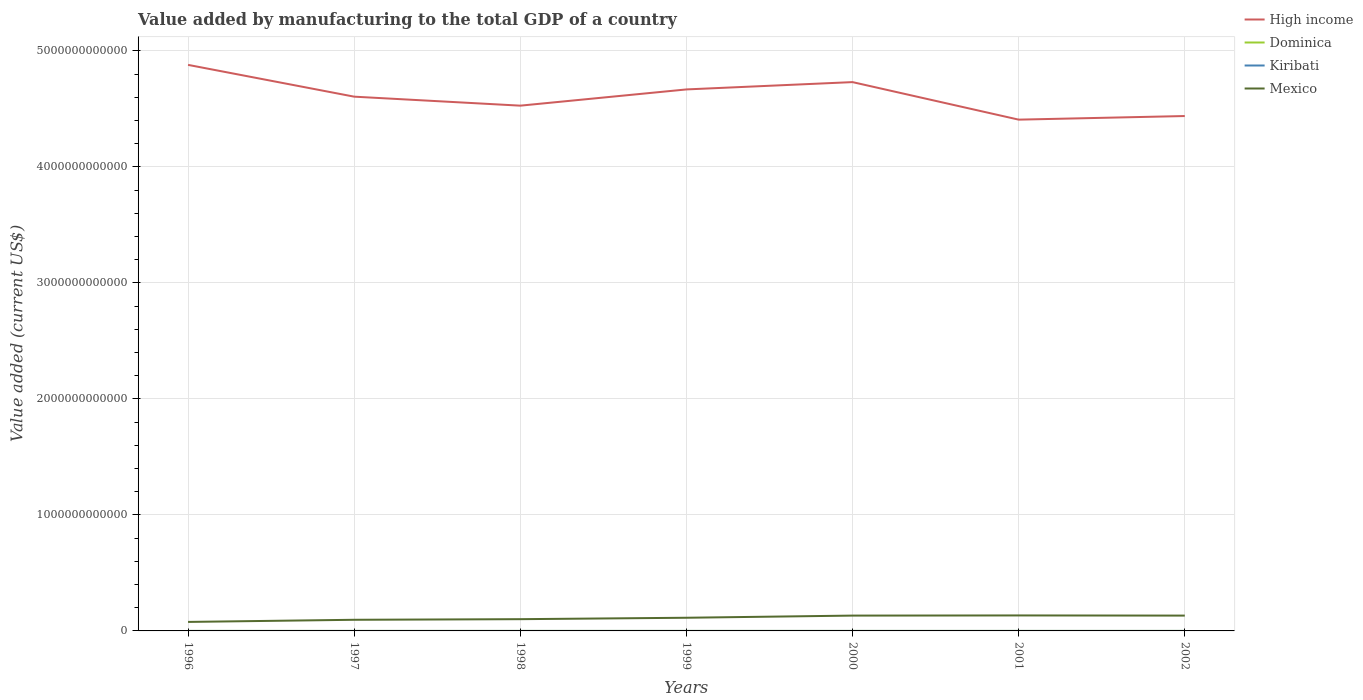Does the line corresponding to Mexico intersect with the line corresponding to Dominica?
Your response must be concise. No. Across all years, what is the maximum value added by manufacturing to the total GDP in Mexico?
Offer a terse response. 7.76e+1. What is the total value added by manufacturing to the total GDP in Mexico in the graph?
Offer a terse response. -5.45e+1. What is the difference between the highest and the second highest value added by manufacturing to the total GDP in Dominica?
Offer a very short reply. 1.43e+07. What is the difference between the highest and the lowest value added by manufacturing to the total GDP in Mexico?
Your answer should be compact. 4. Is the value added by manufacturing to the total GDP in Dominica strictly greater than the value added by manufacturing to the total GDP in High income over the years?
Make the answer very short. Yes. How many lines are there?
Your answer should be compact. 4. What is the difference between two consecutive major ticks on the Y-axis?
Provide a succinct answer. 1.00e+12. Are the values on the major ticks of Y-axis written in scientific E-notation?
Keep it short and to the point. No. Where does the legend appear in the graph?
Give a very brief answer. Top right. How are the legend labels stacked?
Your answer should be compact. Vertical. What is the title of the graph?
Ensure brevity in your answer.  Value added by manufacturing to the total GDP of a country. What is the label or title of the Y-axis?
Your answer should be compact. Value added (current US$). What is the Value added (current US$) in High income in 1996?
Give a very brief answer. 4.88e+12. What is the Value added (current US$) in Dominica in 1996?
Your response must be concise. 1.46e+07. What is the Value added (current US$) in Kiribati in 1996?
Your answer should be compact. 3.55e+06. What is the Value added (current US$) in Mexico in 1996?
Your response must be concise. 7.76e+1. What is the Value added (current US$) in High income in 1997?
Give a very brief answer. 4.61e+12. What is the Value added (current US$) in Dominica in 1997?
Offer a very short reply. 1.57e+07. What is the Value added (current US$) in Kiribati in 1997?
Make the answer very short. 3.47e+06. What is the Value added (current US$) in Mexico in 1997?
Ensure brevity in your answer.  9.60e+1. What is the Value added (current US$) in High income in 1998?
Keep it short and to the point. 4.53e+12. What is the Value added (current US$) in Dominica in 1998?
Make the answer very short. 1.88e+07. What is the Value added (current US$) of Kiribati in 1998?
Your answer should be compact. 3.13e+06. What is the Value added (current US$) in Mexico in 1998?
Your answer should be compact. 1.01e+11. What is the Value added (current US$) of High income in 1999?
Make the answer very short. 4.67e+12. What is the Value added (current US$) of Dominica in 1999?
Give a very brief answer. 1.83e+07. What is the Value added (current US$) of Kiribati in 1999?
Your answer should be compact. 3.52e+06. What is the Value added (current US$) of Mexico in 1999?
Your answer should be compact. 1.14e+11. What is the Value added (current US$) in High income in 2000?
Your answer should be compact. 4.73e+12. What is the Value added (current US$) in Dominica in 2000?
Ensure brevity in your answer.  2.29e+07. What is the Value added (current US$) of Kiribati in 2000?
Keep it short and to the point. 2.98e+06. What is the Value added (current US$) of Mexico in 2000?
Your response must be concise. 1.32e+11. What is the Value added (current US$) of High income in 2001?
Ensure brevity in your answer.  4.41e+12. What is the Value added (current US$) in Dominica in 2001?
Give a very brief answer. 2.42e+07. What is the Value added (current US$) in Kiribati in 2001?
Make the answer very short. 2.78e+06. What is the Value added (current US$) of Mexico in 2001?
Keep it short and to the point. 1.33e+11. What is the Value added (current US$) in High income in 2002?
Give a very brief answer. 4.44e+12. What is the Value added (current US$) in Dominica in 2002?
Your answer should be compact. 2.89e+07. What is the Value added (current US$) of Kiribati in 2002?
Ensure brevity in your answer.  2.85e+06. What is the Value added (current US$) of Mexico in 2002?
Offer a very short reply. 1.32e+11. Across all years, what is the maximum Value added (current US$) in High income?
Keep it short and to the point. 4.88e+12. Across all years, what is the maximum Value added (current US$) in Dominica?
Make the answer very short. 2.89e+07. Across all years, what is the maximum Value added (current US$) of Kiribati?
Offer a terse response. 3.55e+06. Across all years, what is the maximum Value added (current US$) in Mexico?
Offer a terse response. 1.33e+11. Across all years, what is the minimum Value added (current US$) in High income?
Ensure brevity in your answer.  4.41e+12. Across all years, what is the minimum Value added (current US$) in Dominica?
Give a very brief answer. 1.46e+07. Across all years, what is the minimum Value added (current US$) in Kiribati?
Make the answer very short. 2.78e+06. Across all years, what is the minimum Value added (current US$) in Mexico?
Keep it short and to the point. 7.76e+1. What is the total Value added (current US$) in High income in the graph?
Offer a very short reply. 3.23e+13. What is the total Value added (current US$) in Dominica in the graph?
Ensure brevity in your answer.  1.43e+08. What is the total Value added (current US$) in Kiribati in the graph?
Provide a succinct answer. 2.23e+07. What is the total Value added (current US$) of Mexico in the graph?
Provide a short and direct response. 7.86e+11. What is the difference between the Value added (current US$) of High income in 1996 and that in 1997?
Your answer should be very brief. 2.74e+11. What is the difference between the Value added (current US$) of Dominica in 1996 and that in 1997?
Give a very brief answer. -1.06e+06. What is the difference between the Value added (current US$) in Kiribati in 1996 and that in 1997?
Ensure brevity in your answer.  8.27e+04. What is the difference between the Value added (current US$) in Mexico in 1996 and that in 1997?
Ensure brevity in your answer.  -1.84e+1. What is the difference between the Value added (current US$) in High income in 1996 and that in 1998?
Provide a short and direct response. 3.52e+11. What is the difference between the Value added (current US$) in Dominica in 1996 and that in 1998?
Make the answer very short. -4.21e+06. What is the difference between the Value added (current US$) in Kiribati in 1996 and that in 1998?
Provide a succinct answer. 4.20e+05. What is the difference between the Value added (current US$) of Mexico in 1996 and that in 1998?
Make the answer very short. -2.37e+1. What is the difference between the Value added (current US$) of High income in 1996 and that in 1999?
Give a very brief answer. 2.12e+11. What is the difference between the Value added (current US$) in Dominica in 1996 and that in 1999?
Give a very brief answer. -3.66e+06. What is the difference between the Value added (current US$) in Kiribati in 1996 and that in 1999?
Offer a very short reply. 3.37e+04. What is the difference between the Value added (current US$) in Mexico in 1996 and that in 1999?
Ensure brevity in your answer.  -3.60e+1. What is the difference between the Value added (current US$) in High income in 1996 and that in 2000?
Offer a terse response. 1.49e+11. What is the difference between the Value added (current US$) of Dominica in 1996 and that in 2000?
Make the answer very short. -8.29e+06. What is the difference between the Value added (current US$) of Kiribati in 1996 and that in 2000?
Provide a succinct answer. 5.76e+05. What is the difference between the Value added (current US$) in Mexico in 1996 and that in 2000?
Keep it short and to the point. -5.45e+1. What is the difference between the Value added (current US$) of High income in 1996 and that in 2001?
Offer a terse response. 4.72e+11. What is the difference between the Value added (current US$) in Dominica in 1996 and that in 2001?
Ensure brevity in your answer.  -9.57e+06. What is the difference between the Value added (current US$) in Kiribati in 1996 and that in 2001?
Ensure brevity in your answer.  7.70e+05. What is the difference between the Value added (current US$) in Mexico in 1996 and that in 2001?
Provide a succinct answer. -5.58e+1. What is the difference between the Value added (current US$) in High income in 1996 and that in 2002?
Keep it short and to the point. 4.41e+11. What is the difference between the Value added (current US$) of Dominica in 1996 and that in 2002?
Give a very brief answer. -1.43e+07. What is the difference between the Value added (current US$) of Kiribati in 1996 and that in 2002?
Offer a terse response. 7.08e+05. What is the difference between the Value added (current US$) of Mexico in 1996 and that in 2002?
Give a very brief answer. -5.45e+1. What is the difference between the Value added (current US$) of High income in 1997 and that in 1998?
Keep it short and to the point. 7.75e+1. What is the difference between the Value added (current US$) of Dominica in 1997 and that in 1998?
Offer a very short reply. -3.15e+06. What is the difference between the Value added (current US$) in Kiribati in 1997 and that in 1998?
Keep it short and to the point. 3.37e+05. What is the difference between the Value added (current US$) in Mexico in 1997 and that in 1998?
Your answer should be very brief. -5.27e+09. What is the difference between the Value added (current US$) of High income in 1997 and that in 1999?
Keep it short and to the point. -6.24e+1. What is the difference between the Value added (current US$) in Dominica in 1997 and that in 1999?
Offer a very short reply. -2.60e+06. What is the difference between the Value added (current US$) of Kiribati in 1997 and that in 1999?
Ensure brevity in your answer.  -4.90e+04. What is the difference between the Value added (current US$) of Mexico in 1997 and that in 1999?
Make the answer very short. -1.76e+1. What is the difference between the Value added (current US$) in High income in 1997 and that in 2000?
Your response must be concise. -1.25e+11. What is the difference between the Value added (current US$) of Dominica in 1997 and that in 2000?
Your response must be concise. -7.23e+06. What is the difference between the Value added (current US$) in Kiribati in 1997 and that in 2000?
Offer a very short reply. 4.93e+05. What is the difference between the Value added (current US$) of Mexico in 1997 and that in 2000?
Provide a short and direct response. -3.61e+1. What is the difference between the Value added (current US$) in High income in 1997 and that in 2001?
Make the answer very short. 1.98e+11. What is the difference between the Value added (current US$) in Dominica in 1997 and that in 2001?
Offer a terse response. -8.51e+06. What is the difference between the Value added (current US$) in Kiribati in 1997 and that in 2001?
Your answer should be very brief. 6.88e+05. What is the difference between the Value added (current US$) of Mexico in 1997 and that in 2001?
Ensure brevity in your answer.  -3.74e+1. What is the difference between the Value added (current US$) in High income in 1997 and that in 2002?
Your answer should be very brief. 1.67e+11. What is the difference between the Value added (current US$) of Dominica in 1997 and that in 2002?
Provide a succinct answer. -1.32e+07. What is the difference between the Value added (current US$) in Kiribati in 1997 and that in 2002?
Your answer should be very brief. 6.25e+05. What is the difference between the Value added (current US$) of Mexico in 1997 and that in 2002?
Your response must be concise. -3.61e+1. What is the difference between the Value added (current US$) of High income in 1998 and that in 1999?
Keep it short and to the point. -1.40e+11. What is the difference between the Value added (current US$) of Dominica in 1998 and that in 1999?
Provide a short and direct response. 5.56e+05. What is the difference between the Value added (current US$) of Kiribati in 1998 and that in 1999?
Make the answer very short. -3.86e+05. What is the difference between the Value added (current US$) in Mexico in 1998 and that in 1999?
Your answer should be compact. -1.23e+1. What is the difference between the Value added (current US$) of High income in 1998 and that in 2000?
Your answer should be compact. -2.03e+11. What is the difference between the Value added (current US$) of Dominica in 1998 and that in 2000?
Offer a very short reply. -4.08e+06. What is the difference between the Value added (current US$) in Kiribati in 1998 and that in 2000?
Make the answer very short. 1.56e+05. What is the difference between the Value added (current US$) in Mexico in 1998 and that in 2000?
Give a very brief answer. -3.08e+1. What is the difference between the Value added (current US$) in High income in 1998 and that in 2001?
Offer a terse response. 1.21e+11. What is the difference between the Value added (current US$) in Dominica in 1998 and that in 2001?
Your answer should be very brief. -5.36e+06. What is the difference between the Value added (current US$) of Kiribati in 1998 and that in 2001?
Keep it short and to the point. 3.51e+05. What is the difference between the Value added (current US$) of Mexico in 1998 and that in 2001?
Make the answer very short. -3.21e+1. What is the difference between the Value added (current US$) in High income in 1998 and that in 2002?
Keep it short and to the point. 8.95e+1. What is the difference between the Value added (current US$) of Dominica in 1998 and that in 2002?
Provide a short and direct response. -1.01e+07. What is the difference between the Value added (current US$) of Kiribati in 1998 and that in 2002?
Offer a terse response. 2.88e+05. What is the difference between the Value added (current US$) in Mexico in 1998 and that in 2002?
Keep it short and to the point. -3.09e+1. What is the difference between the Value added (current US$) of High income in 1999 and that in 2000?
Provide a short and direct response. -6.31e+1. What is the difference between the Value added (current US$) of Dominica in 1999 and that in 2000?
Your answer should be very brief. -4.63e+06. What is the difference between the Value added (current US$) of Kiribati in 1999 and that in 2000?
Your answer should be very brief. 5.42e+05. What is the difference between the Value added (current US$) in Mexico in 1999 and that in 2000?
Offer a very short reply. -1.85e+1. What is the difference between the Value added (current US$) in High income in 1999 and that in 2001?
Your answer should be very brief. 2.60e+11. What is the difference between the Value added (current US$) of Dominica in 1999 and that in 2001?
Keep it short and to the point. -5.92e+06. What is the difference between the Value added (current US$) of Kiribati in 1999 and that in 2001?
Offer a terse response. 7.37e+05. What is the difference between the Value added (current US$) of Mexico in 1999 and that in 2001?
Your answer should be compact. -1.98e+1. What is the difference between the Value added (current US$) in High income in 1999 and that in 2002?
Offer a very short reply. 2.29e+11. What is the difference between the Value added (current US$) of Dominica in 1999 and that in 2002?
Your answer should be very brief. -1.06e+07. What is the difference between the Value added (current US$) of Kiribati in 1999 and that in 2002?
Make the answer very short. 6.74e+05. What is the difference between the Value added (current US$) in Mexico in 1999 and that in 2002?
Provide a short and direct response. -1.85e+1. What is the difference between the Value added (current US$) in High income in 2000 and that in 2001?
Provide a succinct answer. 3.24e+11. What is the difference between the Value added (current US$) in Dominica in 2000 and that in 2001?
Your answer should be compact. -1.28e+06. What is the difference between the Value added (current US$) in Kiribati in 2000 and that in 2001?
Make the answer very short. 1.95e+05. What is the difference between the Value added (current US$) in Mexico in 2000 and that in 2001?
Make the answer very short. -1.31e+09. What is the difference between the Value added (current US$) in High income in 2000 and that in 2002?
Make the answer very short. 2.92e+11. What is the difference between the Value added (current US$) in Dominica in 2000 and that in 2002?
Ensure brevity in your answer.  -6.01e+06. What is the difference between the Value added (current US$) of Kiribati in 2000 and that in 2002?
Offer a terse response. 1.32e+05. What is the difference between the Value added (current US$) of Mexico in 2000 and that in 2002?
Your answer should be compact. -2.04e+07. What is the difference between the Value added (current US$) of High income in 2001 and that in 2002?
Provide a short and direct response. -3.11e+1. What is the difference between the Value added (current US$) of Dominica in 2001 and that in 2002?
Your answer should be compact. -4.72e+06. What is the difference between the Value added (current US$) in Kiribati in 2001 and that in 2002?
Make the answer very short. -6.24e+04. What is the difference between the Value added (current US$) in Mexico in 2001 and that in 2002?
Your response must be concise. 1.29e+09. What is the difference between the Value added (current US$) in High income in 1996 and the Value added (current US$) in Dominica in 1997?
Your response must be concise. 4.88e+12. What is the difference between the Value added (current US$) of High income in 1996 and the Value added (current US$) of Kiribati in 1997?
Make the answer very short. 4.88e+12. What is the difference between the Value added (current US$) of High income in 1996 and the Value added (current US$) of Mexico in 1997?
Make the answer very short. 4.78e+12. What is the difference between the Value added (current US$) of Dominica in 1996 and the Value added (current US$) of Kiribati in 1997?
Offer a terse response. 1.11e+07. What is the difference between the Value added (current US$) of Dominica in 1996 and the Value added (current US$) of Mexico in 1997?
Offer a very short reply. -9.60e+1. What is the difference between the Value added (current US$) of Kiribati in 1996 and the Value added (current US$) of Mexico in 1997?
Provide a short and direct response. -9.60e+1. What is the difference between the Value added (current US$) of High income in 1996 and the Value added (current US$) of Dominica in 1998?
Your response must be concise. 4.88e+12. What is the difference between the Value added (current US$) of High income in 1996 and the Value added (current US$) of Kiribati in 1998?
Ensure brevity in your answer.  4.88e+12. What is the difference between the Value added (current US$) in High income in 1996 and the Value added (current US$) in Mexico in 1998?
Your answer should be very brief. 4.78e+12. What is the difference between the Value added (current US$) of Dominica in 1996 and the Value added (current US$) of Kiribati in 1998?
Offer a terse response. 1.15e+07. What is the difference between the Value added (current US$) of Dominica in 1996 and the Value added (current US$) of Mexico in 1998?
Ensure brevity in your answer.  -1.01e+11. What is the difference between the Value added (current US$) in Kiribati in 1996 and the Value added (current US$) in Mexico in 1998?
Your response must be concise. -1.01e+11. What is the difference between the Value added (current US$) in High income in 1996 and the Value added (current US$) in Dominica in 1999?
Provide a short and direct response. 4.88e+12. What is the difference between the Value added (current US$) in High income in 1996 and the Value added (current US$) in Kiribati in 1999?
Give a very brief answer. 4.88e+12. What is the difference between the Value added (current US$) of High income in 1996 and the Value added (current US$) of Mexico in 1999?
Make the answer very short. 4.77e+12. What is the difference between the Value added (current US$) in Dominica in 1996 and the Value added (current US$) in Kiribati in 1999?
Provide a short and direct response. 1.11e+07. What is the difference between the Value added (current US$) of Dominica in 1996 and the Value added (current US$) of Mexico in 1999?
Give a very brief answer. -1.14e+11. What is the difference between the Value added (current US$) in Kiribati in 1996 and the Value added (current US$) in Mexico in 1999?
Provide a succinct answer. -1.14e+11. What is the difference between the Value added (current US$) in High income in 1996 and the Value added (current US$) in Dominica in 2000?
Offer a very short reply. 4.88e+12. What is the difference between the Value added (current US$) of High income in 1996 and the Value added (current US$) of Kiribati in 2000?
Give a very brief answer. 4.88e+12. What is the difference between the Value added (current US$) in High income in 1996 and the Value added (current US$) in Mexico in 2000?
Your response must be concise. 4.75e+12. What is the difference between the Value added (current US$) of Dominica in 1996 and the Value added (current US$) of Kiribati in 2000?
Offer a very short reply. 1.16e+07. What is the difference between the Value added (current US$) of Dominica in 1996 and the Value added (current US$) of Mexico in 2000?
Provide a short and direct response. -1.32e+11. What is the difference between the Value added (current US$) in Kiribati in 1996 and the Value added (current US$) in Mexico in 2000?
Offer a very short reply. -1.32e+11. What is the difference between the Value added (current US$) in High income in 1996 and the Value added (current US$) in Dominica in 2001?
Your answer should be very brief. 4.88e+12. What is the difference between the Value added (current US$) of High income in 1996 and the Value added (current US$) of Kiribati in 2001?
Your answer should be very brief. 4.88e+12. What is the difference between the Value added (current US$) of High income in 1996 and the Value added (current US$) of Mexico in 2001?
Your answer should be very brief. 4.75e+12. What is the difference between the Value added (current US$) of Dominica in 1996 and the Value added (current US$) of Kiribati in 2001?
Provide a short and direct response. 1.18e+07. What is the difference between the Value added (current US$) of Dominica in 1996 and the Value added (current US$) of Mexico in 2001?
Your answer should be very brief. -1.33e+11. What is the difference between the Value added (current US$) of Kiribati in 1996 and the Value added (current US$) of Mexico in 2001?
Give a very brief answer. -1.33e+11. What is the difference between the Value added (current US$) in High income in 1996 and the Value added (current US$) in Dominica in 2002?
Offer a very short reply. 4.88e+12. What is the difference between the Value added (current US$) in High income in 1996 and the Value added (current US$) in Kiribati in 2002?
Provide a succinct answer. 4.88e+12. What is the difference between the Value added (current US$) in High income in 1996 and the Value added (current US$) in Mexico in 2002?
Provide a succinct answer. 4.75e+12. What is the difference between the Value added (current US$) in Dominica in 1996 and the Value added (current US$) in Kiribati in 2002?
Provide a succinct answer. 1.18e+07. What is the difference between the Value added (current US$) in Dominica in 1996 and the Value added (current US$) in Mexico in 2002?
Keep it short and to the point. -1.32e+11. What is the difference between the Value added (current US$) in Kiribati in 1996 and the Value added (current US$) in Mexico in 2002?
Your answer should be very brief. -1.32e+11. What is the difference between the Value added (current US$) in High income in 1997 and the Value added (current US$) in Dominica in 1998?
Provide a short and direct response. 4.61e+12. What is the difference between the Value added (current US$) of High income in 1997 and the Value added (current US$) of Kiribati in 1998?
Offer a very short reply. 4.61e+12. What is the difference between the Value added (current US$) in High income in 1997 and the Value added (current US$) in Mexico in 1998?
Give a very brief answer. 4.50e+12. What is the difference between the Value added (current US$) in Dominica in 1997 and the Value added (current US$) in Kiribati in 1998?
Provide a succinct answer. 1.25e+07. What is the difference between the Value added (current US$) of Dominica in 1997 and the Value added (current US$) of Mexico in 1998?
Provide a short and direct response. -1.01e+11. What is the difference between the Value added (current US$) of Kiribati in 1997 and the Value added (current US$) of Mexico in 1998?
Provide a succinct answer. -1.01e+11. What is the difference between the Value added (current US$) of High income in 1997 and the Value added (current US$) of Dominica in 1999?
Your answer should be compact. 4.61e+12. What is the difference between the Value added (current US$) in High income in 1997 and the Value added (current US$) in Kiribati in 1999?
Keep it short and to the point. 4.61e+12. What is the difference between the Value added (current US$) of High income in 1997 and the Value added (current US$) of Mexico in 1999?
Your answer should be very brief. 4.49e+12. What is the difference between the Value added (current US$) of Dominica in 1997 and the Value added (current US$) of Kiribati in 1999?
Keep it short and to the point. 1.21e+07. What is the difference between the Value added (current US$) of Dominica in 1997 and the Value added (current US$) of Mexico in 1999?
Give a very brief answer. -1.14e+11. What is the difference between the Value added (current US$) of Kiribati in 1997 and the Value added (current US$) of Mexico in 1999?
Your answer should be very brief. -1.14e+11. What is the difference between the Value added (current US$) in High income in 1997 and the Value added (current US$) in Dominica in 2000?
Provide a short and direct response. 4.61e+12. What is the difference between the Value added (current US$) in High income in 1997 and the Value added (current US$) in Kiribati in 2000?
Offer a terse response. 4.61e+12. What is the difference between the Value added (current US$) in High income in 1997 and the Value added (current US$) in Mexico in 2000?
Offer a very short reply. 4.47e+12. What is the difference between the Value added (current US$) of Dominica in 1997 and the Value added (current US$) of Kiribati in 2000?
Your response must be concise. 1.27e+07. What is the difference between the Value added (current US$) in Dominica in 1997 and the Value added (current US$) in Mexico in 2000?
Provide a succinct answer. -1.32e+11. What is the difference between the Value added (current US$) of Kiribati in 1997 and the Value added (current US$) of Mexico in 2000?
Ensure brevity in your answer.  -1.32e+11. What is the difference between the Value added (current US$) of High income in 1997 and the Value added (current US$) of Dominica in 2001?
Make the answer very short. 4.61e+12. What is the difference between the Value added (current US$) in High income in 1997 and the Value added (current US$) in Kiribati in 2001?
Make the answer very short. 4.61e+12. What is the difference between the Value added (current US$) in High income in 1997 and the Value added (current US$) in Mexico in 2001?
Provide a succinct answer. 4.47e+12. What is the difference between the Value added (current US$) of Dominica in 1997 and the Value added (current US$) of Kiribati in 2001?
Keep it short and to the point. 1.29e+07. What is the difference between the Value added (current US$) in Dominica in 1997 and the Value added (current US$) in Mexico in 2001?
Ensure brevity in your answer.  -1.33e+11. What is the difference between the Value added (current US$) of Kiribati in 1997 and the Value added (current US$) of Mexico in 2001?
Offer a terse response. -1.33e+11. What is the difference between the Value added (current US$) in High income in 1997 and the Value added (current US$) in Dominica in 2002?
Offer a very short reply. 4.61e+12. What is the difference between the Value added (current US$) of High income in 1997 and the Value added (current US$) of Kiribati in 2002?
Ensure brevity in your answer.  4.61e+12. What is the difference between the Value added (current US$) in High income in 1997 and the Value added (current US$) in Mexico in 2002?
Make the answer very short. 4.47e+12. What is the difference between the Value added (current US$) of Dominica in 1997 and the Value added (current US$) of Kiribati in 2002?
Keep it short and to the point. 1.28e+07. What is the difference between the Value added (current US$) of Dominica in 1997 and the Value added (current US$) of Mexico in 2002?
Provide a short and direct response. -1.32e+11. What is the difference between the Value added (current US$) of Kiribati in 1997 and the Value added (current US$) of Mexico in 2002?
Ensure brevity in your answer.  -1.32e+11. What is the difference between the Value added (current US$) in High income in 1998 and the Value added (current US$) in Dominica in 1999?
Ensure brevity in your answer.  4.53e+12. What is the difference between the Value added (current US$) in High income in 1998 and the Value added (current US$) in Kiribati in 1999?
Provide a short and direct response. 4.53e+12. What is the difference between the Value added (current US$) in High income in 1998 and the Value added (current US$) in Mexico in 1999?
Keep it short and to the point. 4.41e+12. What is the difference between the Value added (current US$) of Dominica in 1998 and the Value added (current US$) of Kiribati in 1999?
Make the answer very short. 1.53e+07. What is the difference between the Value added (current US$) of Dominica in 1998 and the Value added (current US$) of Mexico in 1999?
Ensure brevity in your answer.  -1.14e+11. What is the difference between the Value added (current US$) of Kiribati in 1998 and the Value added (current US$) of Mexico in 1999?
Your answer should be very brief. -1.14e+11. What is the difference between the Value added (current US$) of High income in 1998 and the Value added (current US$) of Dominica in 2000?
Make the answer very short. 4.53e+12. What is the difference between the Value added (current US$) of High income in 1998 and the Value added (current US$) of Kiribati in 2000?
Ensure brevity in your answer.  4.53e+12. What is the difference between the Value added (current US$) of High income in 1998 and the Value added (current US$) of Mexico in 2000?
Give a very brief answer. 4.40e+12. What is the difference between the Value added (current US$) in Dominica in 1998 and the Value added (current US$) in Kiribati in 2000?
Provide a succinct answer. 1.58e+07. What is the difference between the Value added (current US$) of Dominica in 1998 and the Value added (current US$) of Mexico in 2000?
Give a very brief answer. -1.32e+11. What is the difference between the Value added (current US$) in Kiribati in 1998 and the Value added (current US$) in Mexico in 2000?
Provide a succinct answer. -1.32e+11. What is the difference between the Value added (current US$) in High income in 1998 and the Value added (current US$) in Dominica in 2001?
Your response must be concise. 4.53e+12. What is the difference between the Value added (current US$) in High income in 1998 and the Value added (current US$) in Kiribati in 2001?
Ensure brevity in your answer.  4.53e+12. What is the difference between the Value added (current US$) in High income in 1998 and the Value added (current US$) in Mexico in 2001?
Keep it short and to the point. 4.40e+12. What is the difference between the Value added (current US$) in Dominica in 1998 and the Value added (current US$) in Kiribati in 2001?
Your answer should be compact. 1.60e+07. What is the difference between the Value added (current US$) of Dominica in 1998 and the Value added (current US$) of Mexico in 2001?
Your answer should be compact. -1.33e+11. What is the difference between the Value added (current US$) of Kiribati in 1998 and the Value added (current US$) of Mexico in 2001?
Keep it short and to the point. -1.33e+11. What is the difference between the Value added (current US$) of High income in 1998 and the Value added (current US$) of Dominica in 2002?
Keep it short and to the point. 4.53e+12. What is the difference between the Value added (current US$) of High income in 1998 and the Value added (current US$) of Kiribati in 2002?
Offer a terse response. 4.53e+12. What is the difference between the Value added (current US$) in High income in 1998 and the Value added (current US$) in Mexico in 2002?
Keep it short and to the point. 4.40e+12. What is the difference between the Value added (current US$) of Dominica in 1998 and the Value added (current US$) of Kiribati in 2002?
Provide a short and direct response. 1.60e+07. What is the difference between the Value added (current US$) in Dominica in 1998 and the Value added (current US$) in Mexico in 2002?
Offer a terse response. -1.32e+11. What is the difference between the Value added (current US$) of Kiribati in 1998 and the Value added (current US$) of Mexico in 2002?
Your answer should be very brief. -1.32e+11. What is the difference between the Value added (current US$) in High income in 1999 and the Value added (current US$) in Dominica in 2000?
Your response must be concise. 4.67e+12. What is the difference between the Value added (current US$) of High income in 1999 and the Value added (current US$) of Kiribati in 2000?
Offer a very short reply. 4.67e+12. What is the difference between the Value added (current US$) of High income in 1999 and the Value added (current US$) of Mexico in 2000?
Offer a very short reply. 4.54e+12. What is the difference between the Value added (current US$) of Dominica in 1999 and the Value added (current US$) of Kiribati in 2000?
Your response must be concise. 1.53e+07. What is the difference between the Value added (current US$) of Dominica in 1999 and the Value added (current US$) of Mexico in 2000?
Make the answer very short. -1.32e+11. What is the difference between the Value added (current US$) in Kiribati in 1999 and the Value added (current US$) in Mexico in 2000?
Provide a short and direct response. -1.32e+11. What is the difference between the Value added (current US$) of High income in 1999 and the Value added (current US$) of Dominica in 2001?
Your answer should be very brief. 4.67e+12. What is the difference between the Value added (current US$) of High income in 1999 and the Value added (current US$) of Kiribati in 2001?
Make the answer very short. 4.67e+12. What is the difference between the Value added (current US$) of High income in 1999 and the Value added (current US$) of Mexico in 2001?
Your answer should be very brief. 4.54e+12. What is the difference between the Value added (current US$) of Dominica in 1999 and the Value added (current US$) of Kiribati in 2001?
Provide a succinct answer. 1.55e+07. What is the difference between the Value added (current US$) of Dominica in 1999 and the Value added (current US$) of Mexico in 2001?
Provide a short and direct response. -1.33e+11. What is the difference between the Value added (current US$) of Kiribati in 1999 and the Value added (current US$) of Mexico in 2001?
Provide a succinct answer. -1.33e+11. What is the difference between the Value added (current US$) in High income in 1999 and the Value added (current US$) in Dominica in 2002?
Provide a succinct answer. 4.67e+12. What is the difference between the Value added (current US$) in High income in 1999 and the Value added (current US$) in Kiribati in 2002?
Ensure brevity in your answer.  4.67e+12. What is the difference between the Value added (current US$) of High income in 1999 and the Value added (current US$) of Mexico in 2002?
Give a very brief answer. 4.54e+12. What is the difference between the Value added (current US$) of Dominica in 1999 and the Value added (current US$) of Kiribati in 2002?
Make the answer very short. 1.54e+07. What is the difference between the Value added (current US$) in Dominica in 1999 and the Value added (current US$) in Mexico in 2002?
Your answer should be very brief. -1.32e+11. What is the difference between the Value added (current US$) in Kiribati in 1999 and the Value added (current US$) in Mexico in 2002?
Give a very brief answer. -1.32e+11. What is the difference between the Value added (current US$) in High income in 2000 and the Value added (current US$) in Dominica in 2001?
Ensure brevity in your answer.  4.73e+12. What is the difference between the Value added (current US$) of High income in 2000 and the Value added (current US$) of Kiribati in 2001?
Your response must be concise. 4.73e+12. What is the difference between the Value added (current US$) in High income in 2000 and the Value added (current US$) in Mexico in 2001?
Your response must be concise. 4.60e+12. What is the difference between the Value added (current US$) of Dominica in 2000 and the Value added (current US$) of Kiribati in 2001?
Keep it short and to the point. 2.01e+07. What is the difference between the Value added (current US$) of Dominica in 2000 and the Value added (current US$) of Mexico in 2001?
Give a very brief answer. -1.33e+11. What is the difference between the Value added (current US$) in Kiribati in 2000 and the Value added (current US$) in Mexico in 2001?
Your answer should be very brief. -1.33e+11. What is the difference between the Value added (current US$) in High income in 2000 and the Value added (current US$) in Dominica in 2002?
Your answer should be compact. 4.73e+12. What is the difference between the Value added (current US$) in High income in 2000 and the Value added (current US$) in Kiribati in 2002?
Give a very brief answer. 4.73e+12. What is the difference between the Value added (current US$) in High income in 2000 and the Value added (current US$) in Mexico in 2002?
Provide a short and direct response. 4.60e+12. What is the difference between the Value added (current US$) of Dominica in 2000 and the Value added (current US$) of Kiribati in 2002?
Your answer should be very brief. 2.00e+07. What is the difference between the Value added (current US$) in Dominica in 2000 and the Value added (current US$) in Mexico in 2002?
Your answer should be compact. -1.32e+11. What is the difference between the Value added (current US$) in Kiribati in 2000 and the Value added (current US$) in Mexico in 2002?
Your answer should be compact. -1.32e+11. What is the difference between the Value added (current US$) in High income in 2001 and the Value added (current US$) in Dominica in 2002?
Give a very brief answer. 4.41e+12. What is the difference between the Value added (current US$) in High income in 2001 and the Value added (current US$) in Kiribati in 2002?
Make the answer very short. 4.41e+12. What is the difference between the Value added (current US$) in High income in 2001 and the Value added (current US$) in Mexico in 2002?
Keep it short and to the point. 4.28e+12. What is the difference between the Value added (current US$) of Dominica in 2001 and the Value added (current US$) of Kiribati in 2002?
Offer a very short reply. 2.13e+07. What is the difference between the Value added (current US$) in Dominica in 2001 and the Value added (current US$) in Mexico in 2002?
Your answer should be very brief. -1.32e+11. What is the difference between the Value added (current US$) in Kiribati in 2001 and the Value added (current US$) in Mexico in 2002?
Your response must be concise. -1.32e+11. What is the average Value added (current US$) in High income per year?
Provide a succinct answer. 4.61e+12. What is the average Value added (current US$) of Dominica per year?
Your response must be concise. 2.05e+07. What is the average Value added (current US$) in Kiribati per year?
Your answer should be very brief. 3.18e+06. What is the average Value added (current US$) in Mexico per year?
Your answer should be very brief. 1.12e+11. In the year 1996, what is the difference between the Value added (current US$) of High income and Value added (current US$) of Dominica?
Give a very brief answer. 4.88e+12. In the year 1996, what is the difference between the Value added (current US$) of High income and Value added (current US$) of Kiribati?
Provide a succinct answer. 4.88e+12. In the year 1996, what is the difference between the Value added (current US$) in High income and Value added (current US$) in Mexico?
Offer a terse response. 4.80e+12. In the year 1996, what is the difference between the Value added (current US$) in Dominica and Value added (current US$) in Kiribati?
Give a very brief answer. 1.10e+07. In the year 1996, what is the difference between the Value added (current US$) of Dominica and Value added (current US$) of Mexico?
Ensure brevity in your answer.  -7.76e+1. In the year 1996, what is the difference between the Value added (current US$) of Kiribati and Value added (current US$) of Mexico?
Your answer should be very brief. -7.76e+1. In the year 1997, what is the difference between the Value added (current US$) of High income and Value added (current US$) of Dominica?
Offer a terse response. 4.61e+12. In the year 1997, what is the difference between the Value added (current US$) in High income and Value added (current US$) in Kiribati?
Give a very brief answer. 4.61e+12. In the year 1997, what is the difference between the Value added (current US$) of High income and Value added (current US$) of Mexico?
Your answer should be compact. 4.51e+12. In the year 1997, what is the difference between the Value added (current US$) in Dominica and Value added (current US$) in Kiribati?
Keep it short and to the point. 1.22e+07. In the year 1997, what is the difference between the Value added (current US$) in Dominica and Value added (current US$) in Mexico?
Your answer should be very brief. -9.60e+1. In the year 1997, what is the difference between the Value added (current US$) in Kiribati and Value added (current US$) in Mexico?
Your answer should be very brief. -9.60e+1. In the year 1998, what is the difference between the Value added (current US$) of High income and Value added (current US$) of Dominica?
Ensure brevity in your answer.  4.53e+12. In the year 1998, what is the difference between the Value added (current US$) in High income and Value added (current US$) in Kiribati?
Offer a terse response. 4.53e+12. In the year 1998, what is the difference between the Value added (current US$) of High income and Value added (current US$) of Mexico?
Make the answer very short. 4.43e+12. In the year 1998, what is the difference between the Value added (current US$) in Dominica and Value added (current US$) in Kiribati?
Your response must be concise. 1.57e+07. In the year 1998, what is the difference between the Value added (current US$) of Dominica and Value added (current US$) of Mexico?
Keep it short and to the point. -1.01e+11. In the year 1998, what is the difference between the Value added (current US$) of Kiribati and Value added (current US$) of Mexico?
Provide a short and direct response. -1.01e+11. In the year 1999, what is the difference between the Value added (current US$) in High income and Value added (current US$) in Dominica?
Offer a terse response. 4.67e+12. In the year 1999, what is the difference between the Value added (current US$) in High income and Value added (current US$) in Kiribati?
Provide a short and direct response. 4.67e+12. In the year 1999, what is the difference between the Value added (current US$) of High income and Value added (current US$) of Mexico?
Make the answer very short. 4.55e+12. In the year 1999, what is the difference between the Value added (current US$) in Dominica and Value added (current US$) in Kiribati?
Your answer should be compact. 1.47e+07. In the year 1999, what is the difference between the Value added (current US$) of Dominica and Value added (current US$) of Mexico?
Your answer should be very brief. -1.14e+11. In the year 1999, what is the difference between the Value added (current US$) in Kiribati and Value added (current US$) in Mexico?
Provide a succinct answer. -1.14e+11. In the year 2000, what is the difference between the Value added (current US$) in High income and Value added (current US$) in Dominica?
Offer a terse response. 4.73e+12. In the year 2000, what is the difference between the Value added (current US$) in High income and Value added (current US$) in Kiribati?
Keep it short and to the point. 4.73e+12. In the year 2000, what is the difference between the Value added (current US$) in High income and Value added (current US$) in Mexico?
Keep it short and to the point. 4.60e+12. In the year 2000, what is the difference between the Value added (current US$) in Dominica and Value added (current US$) in Kiribati?
Offer a very short reply. 1.99e+07. In the year 2000, what is the difference between the Value added (current US$) of Dominica and Value added (current US$) of Mexico?
Give a very brief answer. -1.32e+11. In the year 2000, what is the difference between the Value added (current US$) of Kiribati and Value added (current US$) of Mexico?
Your answer should be compact. -1.32e+11. In the year 2001, what is the difference between the Value added (current US$) of High income and Value added (current US$) of Dominica?
Provide a short and direct response. 4.41e+12. In the year 2001, what is the difference between the Value added (current US$) in High income and Value added (current US$) in Kiribati?
Make the answer very short. 4.41e+12. In the year 2001, what is the difference between the Value added (current US$) in High income and Value added (current US$) in Mexico?
Your answer should be very brief. 4.27e+12. In the year 2001, what is the difference between the Value added (current US$) in Dominica and Value added (current US$) in Kiribati?
Keep it short and to the point. 2.14e+07. In the year 2001, what is the difference between the Value added (current US$) of Dominica and Value added (current US$) of Mexico?
Make the answer very short. -1.33e+11. In the year 2001, what is the difference between the Value added (current US$) in Kiribati and Value added (current US$) in Mexico?
Your response must be concise. -1.33e+11. In the year 2002, what is the difference between the Value added (current US$) of High income and Value added (current US$) of Dominica?
Make the answer very short. 4.44e+12. In the year 2002, what is the difference between the Value added (current US$) in High income and Value added (current US$) in Kiribati?
Your answer should be very brief. 4.44e+12. In the year 2002, what is the difference between the Value added (current US$) of High income and Value added (current US$) of Mexico?
Your answer should be compact. 4.31e+12. In the year 2002, what is the difference between the Value added (current US$) of Dominica and Value added (current US$) of Kiribati?
Provide a succinct answer. 2.61e+07. In the year 2002, what is the difference between the Value added (current US$) of Dominica and Value added (current US$) of Mexico?
Make the answer very short. -1.32e+11. In the year 2002, what is the difference between the Value added (current US$) of Kiribati and Value added (current US$) of Mexico?
Provide a short and direct response. -1.32e+11. What is the ratio of the Value added (current US$) in High income in 1996 to that in 1997?
Provide a short and direct response. 1.06. What is the ratio of the Value added (current US$) in Dominica in 1996 to that in 1997?
Keep it short and to the point. 0.93. What is the ratio of the Value added (current US$) of Kiribati in 1996 to that in 1997?
Provide a succinct answer. 1.02. What is the ratio of the Value added (current US$) of Mexico in 1996 to that in 1997?
Your answer should be compact. 0.81. What is the ratio of the Value added (current US$) in High income in 1996 to that in 1998?
Your answer should be very brief. 1.08. What is the ratio of the Value added (current US$) in Dominica in 1996 to that in 1998?
Provide a short and direct response. 0.78. What is the ratio of the Value added (current US$) in Kiribati in 1996 to that in 1998?
Your answer should be compact. 1.13. What is the ratio of the Value added (current US$) in Mexico in 1996 to that in 1998?
Your answer should be compact. 0.77. What is the ratio of the Value added (current US$) in High income in 1996 to that in 1999?
Provide a short and direct response. 1.05. What is the ratio of the Value added (current US$) in Dominica in 1996 to that in 1999?
Your answer should be compact. 0.8. What is the ratio of the Value added (current US$) in Kiribati in 1996 to that in 1999?
Offer a very short reply. 1.01. What is the ratio of the Value added (current US$) in Mexico in 1996 to that in 1999?
Provide a short and direct response. 0.68. What is the ratio of the Value added (current US$) in High income in 1996 to that in 2000?
Your answer should be compact. 1.03. What is the ratio of the Value added (current US$) of Dominica in 1996 to that in 2000?
Offer a very short reply. 0.64. What is the ratio of the Value added (current US$) in Kiribati in 1996 to that in 2000?
Your answer should be compact. 1.19. What is the ratio of the Value added (current US$) in Mexico in 1996 to that in 2000?
Make the answer very short. 0.59. What is the ratio of the Value added (current US$) of High income in 1996 to that in 2001?
Your answer should be compact. 1.11. What is the ratio of the Value added (current US$) in Dominica in 1996 to that in 2001?
Your answer should be compact. 0.6. What is the ratio of the Value added (current US$) of Kiribati in 1996 to that in 2001?
Your answer should be compact. 1.28. What is the ratio of the Value added (current US$) in Mexico in 1996 to that in 2001?
Keep it short and to the point. 0.58. What is the ratio of the Value added (current US$) of High income in 1996 to that in 2002?
Provide a succinct answer. 1.1. What is the ratio of the Value added (current US$) of Dominica in 1996 to that in 2002?
Your answer should be compact. 0.51. What is the ratio of the Value added (current US$) of Kiribati in 1996 to that in 2002?
Keep it short and to the point. 1.25. What is the ratio of the Value added (current US$) of Mexico in 1996 to that in 2002?
Provide a succinct answer. 0.59. What is the ratio of the Value added (current US$) in High income in 1997 to that in 1998?
Give a very brief answer. 1.02. What is the ratio of the Value added (current US$) of Dominica in 1997 to that in 1998?
Give a very brief answer. 0.83. What is the ratio of the Value added (current US$) of Kiribati in 1997 to that in 1998?
Provide a short and direct response. 1.11. What is the ratio of the Value added (current US$) in Mexico in 1997 to that in 1998?
Your response must be concise. 0.95. What is the ratio of the Value added (current US$) of High income in 1997 to that in 1999?
Provide a short and direct response. 0.99. What is the ratio of the Value added (current US$) of Dominica in 1997 to that in 1999?
Give a very brief answer. 0.86. What is the ratio of the Value added (current US$) in Kiribati in 1997 to that in 1999?
Give a very brief answer. 0.99. What is the ratio of the Value added (current US$) in Mexico in 1997 to that in 1999?
Provide a succinct answer. 0.85. What is the ratio of the Value added (current US$) in High income in 1997 to that in 2000?
Give a very brief answer. 0.97. What is the ratio of the Value added (current US$) of Dominica in 1997 to that in 2000?
Offer a terse response. 0.68. What is the ratio of the Value added (current US$) of Kiribati in 1997 to that in 2000?
Offer a terse response. 1.17. What is the ratio of the Value added (current US$) of Mexico in 1997 to that in 2000?
Make the answer very short. 0.73. What is the ratio of the Value added (current US$) of High income in 1997 to that in 2001?
Offer a terse response. 1.04. What is the ratio of the Value added (current US$) in Dominica in 1997 to that in 2001?
Provide a short and direct response. 0.65. What is the ratio of the Value added (current US$) of Kiribati in 1997 to that in 2001?
Give a very brief answer. 1.25. What is the ratio of the Value added (current US$) in Mexico in 1997 to that in 2001?
Your answer should be very brief. 0.72. What is the ratio of the Value added (current US$) in High income in 1997 to that in 2002?
Keep it short and to the point. 1.04. What is the ratio of the Value added (current US$) in Dominica in 1997 to that in 2002?
Give a very brief answer. 0.54. What is the ratio of the Value added (current US$) of Kiribati in 1997 to that in 2002?
Give a very brief answer. 1.22. What is the ratio of the Value added (current US$) in Mexico in 1997 to that in 2002?
Provide a short and direct response. 0.73. What is the ratio of the Value added (current US$) in High income in 1998 to that in 1999?
Provide a short and direct response. 0.97. What is the ratio of the Value added (current US$) in Dominica in 1998 to that in 1999?
Make the answer very short. 1.03. What is the ratio of the Value added (current US$) in Kiribati in 1998 to that in 1999?
Your response must be concise. 0.89. What is the ratio of the Value added (current US$) in Mexico in 1998 to that in 1999?
Your answer should be compact. 0.89. What is the ratio of the Value added (current US$) in High income in 1998 to that in 2000?
Your answer should be compact. 0.96. What is the ratio of the Value added (current US$) in Dominica in 1998 to that in 2000?
Offer a very short reply. 0.82. What is the ratio of the Value added (current US$) of Kiribati in 1998 to that in 2000?
Offer a terse response. 1.05. What is the ratio of the Value added (current US$) in Mexico in 1998 to that in 2000?
Offer a very short reply. 0.77. What is the ratio of the Value added (current US$) in High income in 1998 to that in 2001?
Your answer should be very brief. 1.03. What is the ratio of the Value added (current US$) of Dominica in 1998 to that in 2001?
Make the answer very short. 0.78. What is the ratio of the Value added (current US$) in Kiribati in 1998 to that in 2001?
Provide a succinct answer. 1.13. What is the ratio of the Value added (current US$) in Mexico in 1998 to that in 2001?
Provide a succinct answer. 0.76. What is the ratio of the Value added (current US$) in High income in 1998 to that in 2002?
Provide a short and direct response. 1.02. What is the ratio of the Value added (current US$) in Dominica in 1998 to that in 2002?
Offer a very short reply. 0.65. What is the ratio of the Value added (current US$) of Kiribati in 1998 to that in 2002?
Offer a very short reply. 1.1. What is the ratio of the Value added (current US$) in Mexico in 1998 to that in 2002?
Offer a very short reply. 0.77. What is the ratio of the Value added (current US$) of High income in 1999 to that in 2000?
Make the answer very short. 0.99. What is the ratio of the Value added (current US$) of Dominica in 1999 to that in 2000?
Keep it short and to the point. 0.8. What is the ratio of the Value added (current US$) in Kiribati in 1999 to that in 2000?
Ensure brevity in your answer.  1.18. What is the ratio of the Value added (current US$) of Mexico in 1999 to that in 2000?
Your answer should be very brief. 0.86. What is the ratio of the Value added (current US$) in High income in 1999 to that in 2001?
Provide a short and direct response. 1.06. What is the ratio of the Value added (current US$) of Dominica in 1999 to that in 2001?
Your answer should be compact. 0.76. What is the ratio of the Value added (current US$) in Kiribati in 1999 to that in 2001?
Ensure brevity in your answer.  1.26. What is the ratio of the Value added (current US$) in Mexico in 1999 to that in 2001?
Keep it short and to the point. 0.85. What is the ratio of the Value added (current US$) of High income in 1999 to that in 2002?
Provide a succinct answer. 1.05. What is the ratio of the Value added (current US$) in Dominica in 1999 to that in 2002?
Provide a short and direct response. 0.63. What is the ratio of the Value added (current US$) of Kiribati in 1999 to that in 2002?
Keep it short and to the point. 1.24. What is the ratio of the Value added (current US$) in Mexico in 1999 to that in 2002?
Keep it short and to the point. 0.86. What is the ratio of the Value added (current US$) of High income in 2000 to that in 2001?
Provide a succinct answer. 1.07. What is the ratio of the Value added (current US$) of Dominica in 2000 to that in 2001?
Offer a very short reply. 0.95. What is the ratio of the Value added (current US$) in Kiribati in 2000 to that in 2001?
Ensure brevity in your answer.  1.07. What is the ratio of the Value added (current US$) in Mexico in 2000 to that in 2001?
Provide a succinct answer. 0.99. What is the ratio of the Value added (current US$) in High income in 2000 to that in 2002?
Your answer should be very brief. 1.07. What is the ratio of the Value added (current US$) of Dominica in 2000 to that in 2002?
Your answer should be very brief. 0.79. What is the ratio of the Value added (current US$) in Kiribati in 2000 to that in 2002?
Keep it short and to the point. 1.05. What is the ratio of the Value added (current US$) of Mexico in 2000 to that in 2002?
Provide a short and direct response. 1. What is the ratio of the Value added (current US$) of Dominica in 2001 to that in 2002?
Keep it short and to the point. 0.84. What is the ratio of the Value added (current US$) of Kiribati in 2001 to that in 2002?
Make the answer very short. 0.98. What is the ratio of the Value added (current US$) of Mexico in 2001 to that in 2002?
Your response must be concise. 1.01. What is the difference between the highest and the second highest Value added (current US$) of High income?
Give a very brief answer. 1.49e+11. What is the difference between the highest and the second highest Value added (current US$) of Dominica?
Make the answer very short. 4.72e+06. What is the difference between the highest and the second highest Value added (current US$) in Kiribati?
Ensure brevity in your answer.  3.37e+04. What is the difference between the highest and the second highest Value added (current US$) in Mexico?
Offer a very short reply. 1.29e+09. What is the difference between the highest and the lowest Value added (current US$) of High income?
Your response must be concise. 4.72e+11. What is the difference between the highest and the lowest Value added (current US$) in Dominica?
Your answer should be compact. 1.43e+07. What is the difference between the highest and the lowest Value added (current US$) in Kiribati?
Offer a terse response. 7.70e+05. What is the difference between the highest and the lowest Value added (current US$) of Mexico?
Offer a very short reply. 5.58e+1. 